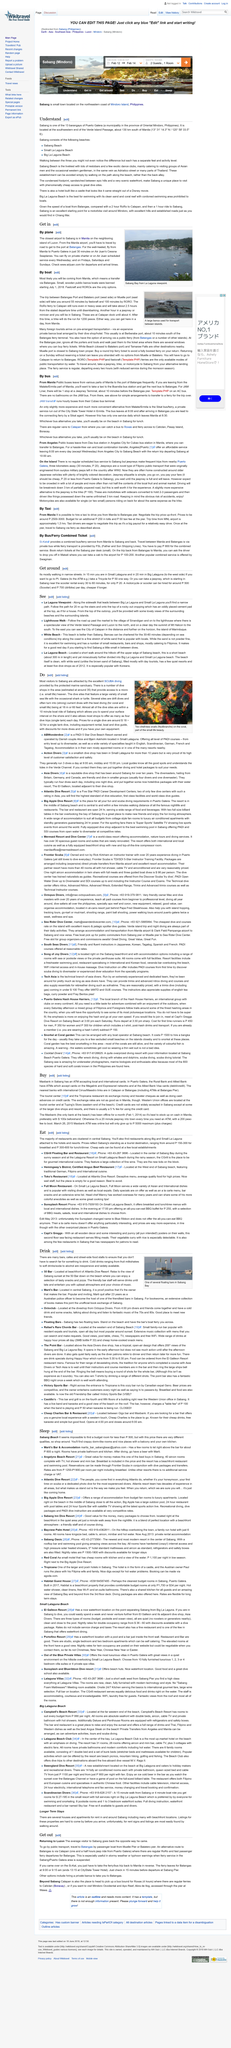Specify some key components in this picture. In Koh Samui, some of the larger drive-through shops and resorts may accept international credit cards, but it is not expected at most of the smaller dive shops. Maxbank in Saban's accepts international credit cards. The Maxbank is the only bank that is located by the beach, as stated in the article "Buy." Marti served as an Australian police officer for 23 years. To reach Sabang from the Manila airport, one must travel by road to the port at Batangas. The above picture portrays Sabang Bay from a La Laguna viewpoint. 